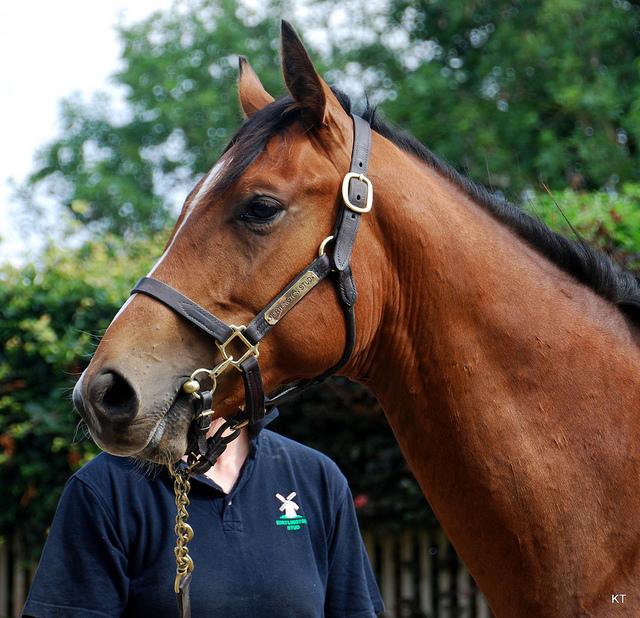How many people's faces do you see?
Quick response, please. 0. Is the horse real?
Quick response, please. Yes. What is the symbol on the women's shirt?
Be succinct. Windmill. 